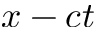Convert formula to latex. <formula><loc_0><loc_0><loc_500><loc_500>x - c t</formula> 